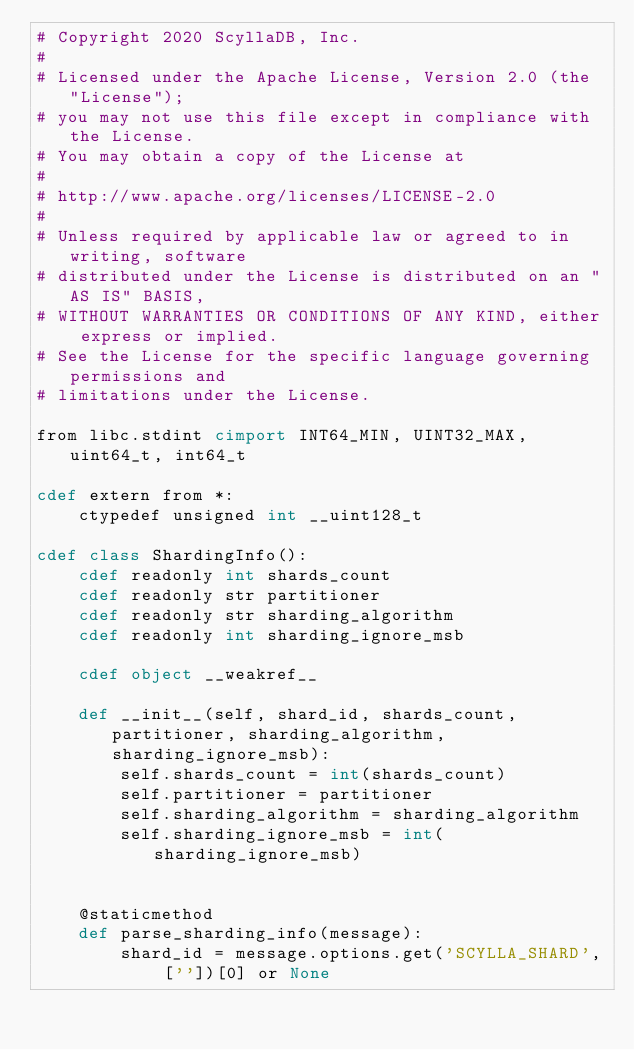Convert code to text. <code><loc_0><loc_0><loc_500><loc_500><_Cython_># Copyright 2020 ScyllaDB, Inc.
#
# Licensed under the Apache License, Version 2.0 (the "License");
# you may not use this file except in compliance with the License.
# You may obtain a copy of the License at
#
# http://www.apache.org/licenses/LICENSE-2.0
#
# Unless required by applicable law or agreed to in writing, software
# distributed under the License is distributed on an "AS IS" BASIS,
# WITHOUT WARRANTIES OR CONDITIONS OF ANY KIND, either express or implied.
# See the License for the specific language governing permissions and
# limitations under the License.

from libc.stdint cimport INT64_MIN, UINT32_MAX, uint64_t, int64_t

cdef extern from *:
    ctypedef unsigned int __uint128_t

cdef class ShardingInfo():
    cdef readonly int shards_count
    cdef readonly str partitioner
    cdef readonly str sharding_algorithm
    cdef readonly int sharding_ignore_msb

    cdef object __weakref__

    def __init__(self, shard_id, shards_count, partitioner, sharding_algorithm, sharding_ignore_msb):
        self.shards_count = int(shards_count)
        self.partitioner = partitioner
        self.sharding_algorithm = sharding_algorithm
        self.sharding_ignore_msb = int(sharding_ignore_msb)


    @staticmethod
    def parse_sharding_info(message):
        shard_id = message.options.get('SCYLLA_SHARD', [''])[0] or None</code> 